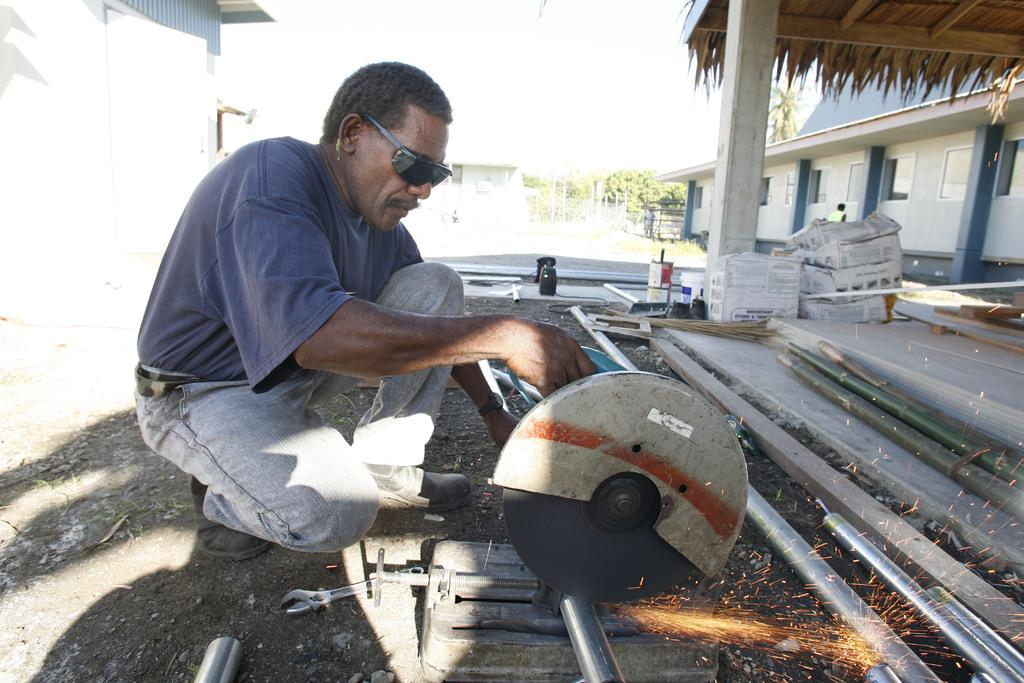What is the man doing in the image? The man is cutting an iron rod in the image. What tool is the man using to cut the iron rod? The man is using a machine to cut the iron rod. What type of clothing is the man wearing? The man is wearing a t-shirt and jeans trousers. What can be seen on the right side of the image? There is a house on the right side of the image. What type of lettuce is being used as a cutting board in the image? There is no lettuce present in the image, and it is not being used as a cutting board. 